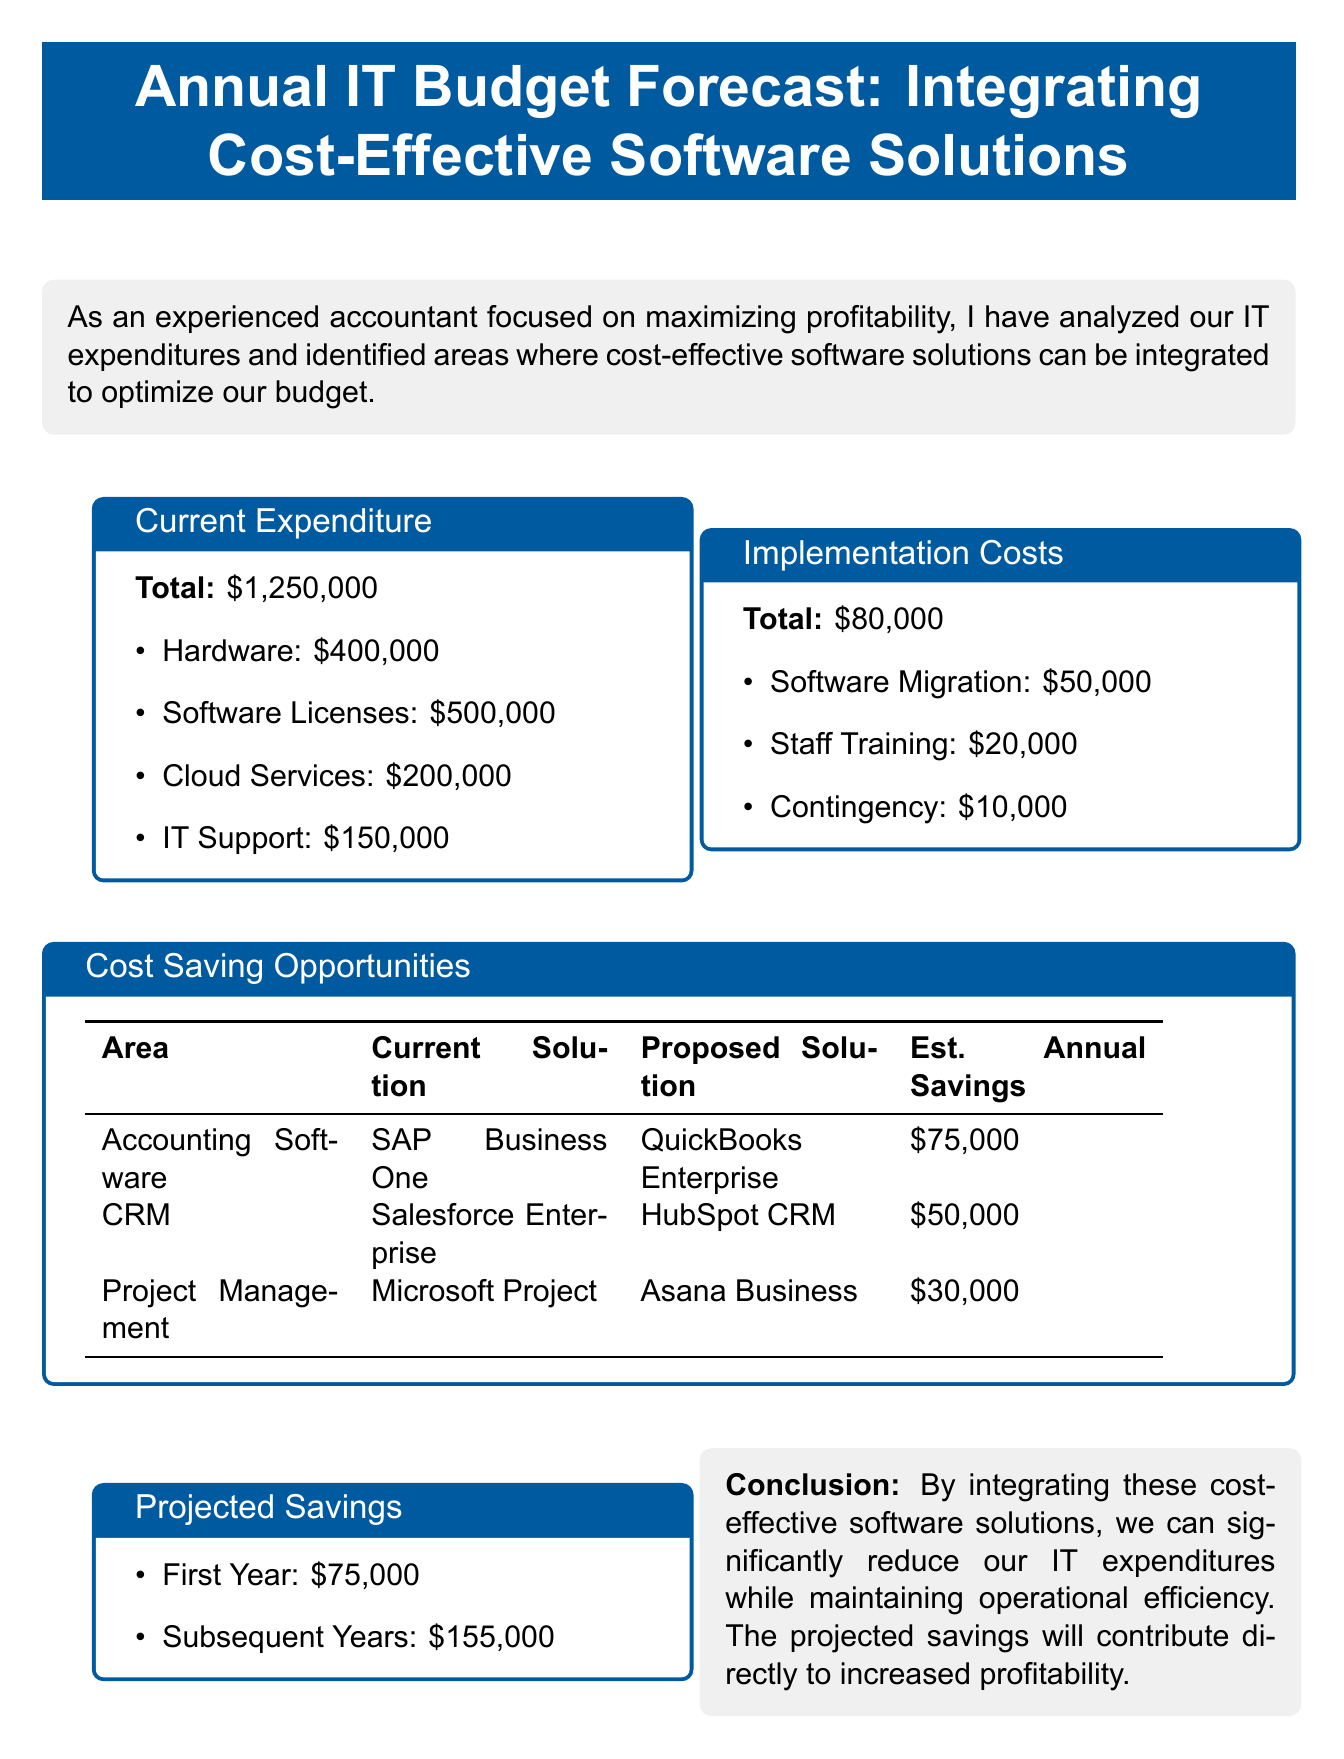What is the total current expenditure? The total current expenditure is stated in the document as $1,250,000.
Answer: $1,250,000 How much is allocated for Software Licenses? The allocated amount for Software Licenses is detailed in the document under the current expenditure breakdown.
Answer: $500,000 What is the estimated annual savings from switching Accounting Software? The estimated annual savings from the proposed Accounting Software solution is given in the cost-saving opportunities section.
Answer: $75,000 What is the total implementation cost? The total implementation cost is summarized in the relevant section of the document.
Answer: $80,000 Who is the current solution provider for Project Management Software? The current solution provider for Project Management Software is specified in the cost-saving opportunities table.
Answer: Microsoft Project How much can the company save in subsequent years after implementing the new solutions? The potential savings for subsequent years is listed under projected savings in the document.
Answer: $155,000 What proposed solution is mentioned for Customer Relationship Management? The proposed solution for Customer Relationship Management is outlined in the cost-saving opportunities section.
Answer: HubSpot CRM What does the conclusion suggest about operational efficiency? The conclusion provides insights into the impact of software solution integration on operational efficiency.
Answer: Maintain operational efficiency 